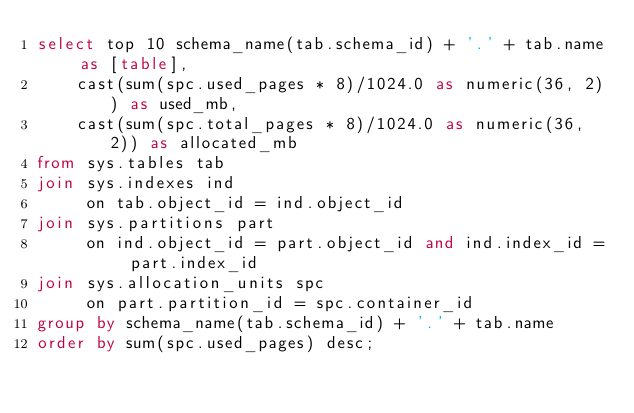<code> <loc_0><loc_0><loc_500><loc_500><_SQL_>select top 10 schema_name(tab.schema_id) + '.' + tab.name as [table], 
    cast(sum(spc.used_pages * 8)/1024.0 as numeric(36, 2)) as used_mb,
    cast(sum(spc.total_pages * 8)/1024.0 as numeric(36, 2)) as allocated_mb
from sys.tables tab
join sys.indexes ind 
     on tab.object_id = ind.object_id
join sys.partitions part 
     on ind.object_id = part.object_id and ind.index_id = part.index_id
join sys.allocation_units spc
     on part.partition_id = spc.container_id
group by schema_name(tab.schema_id) + '.' + tab.name
order by sum(spc.used_pages) desc;
</code> 